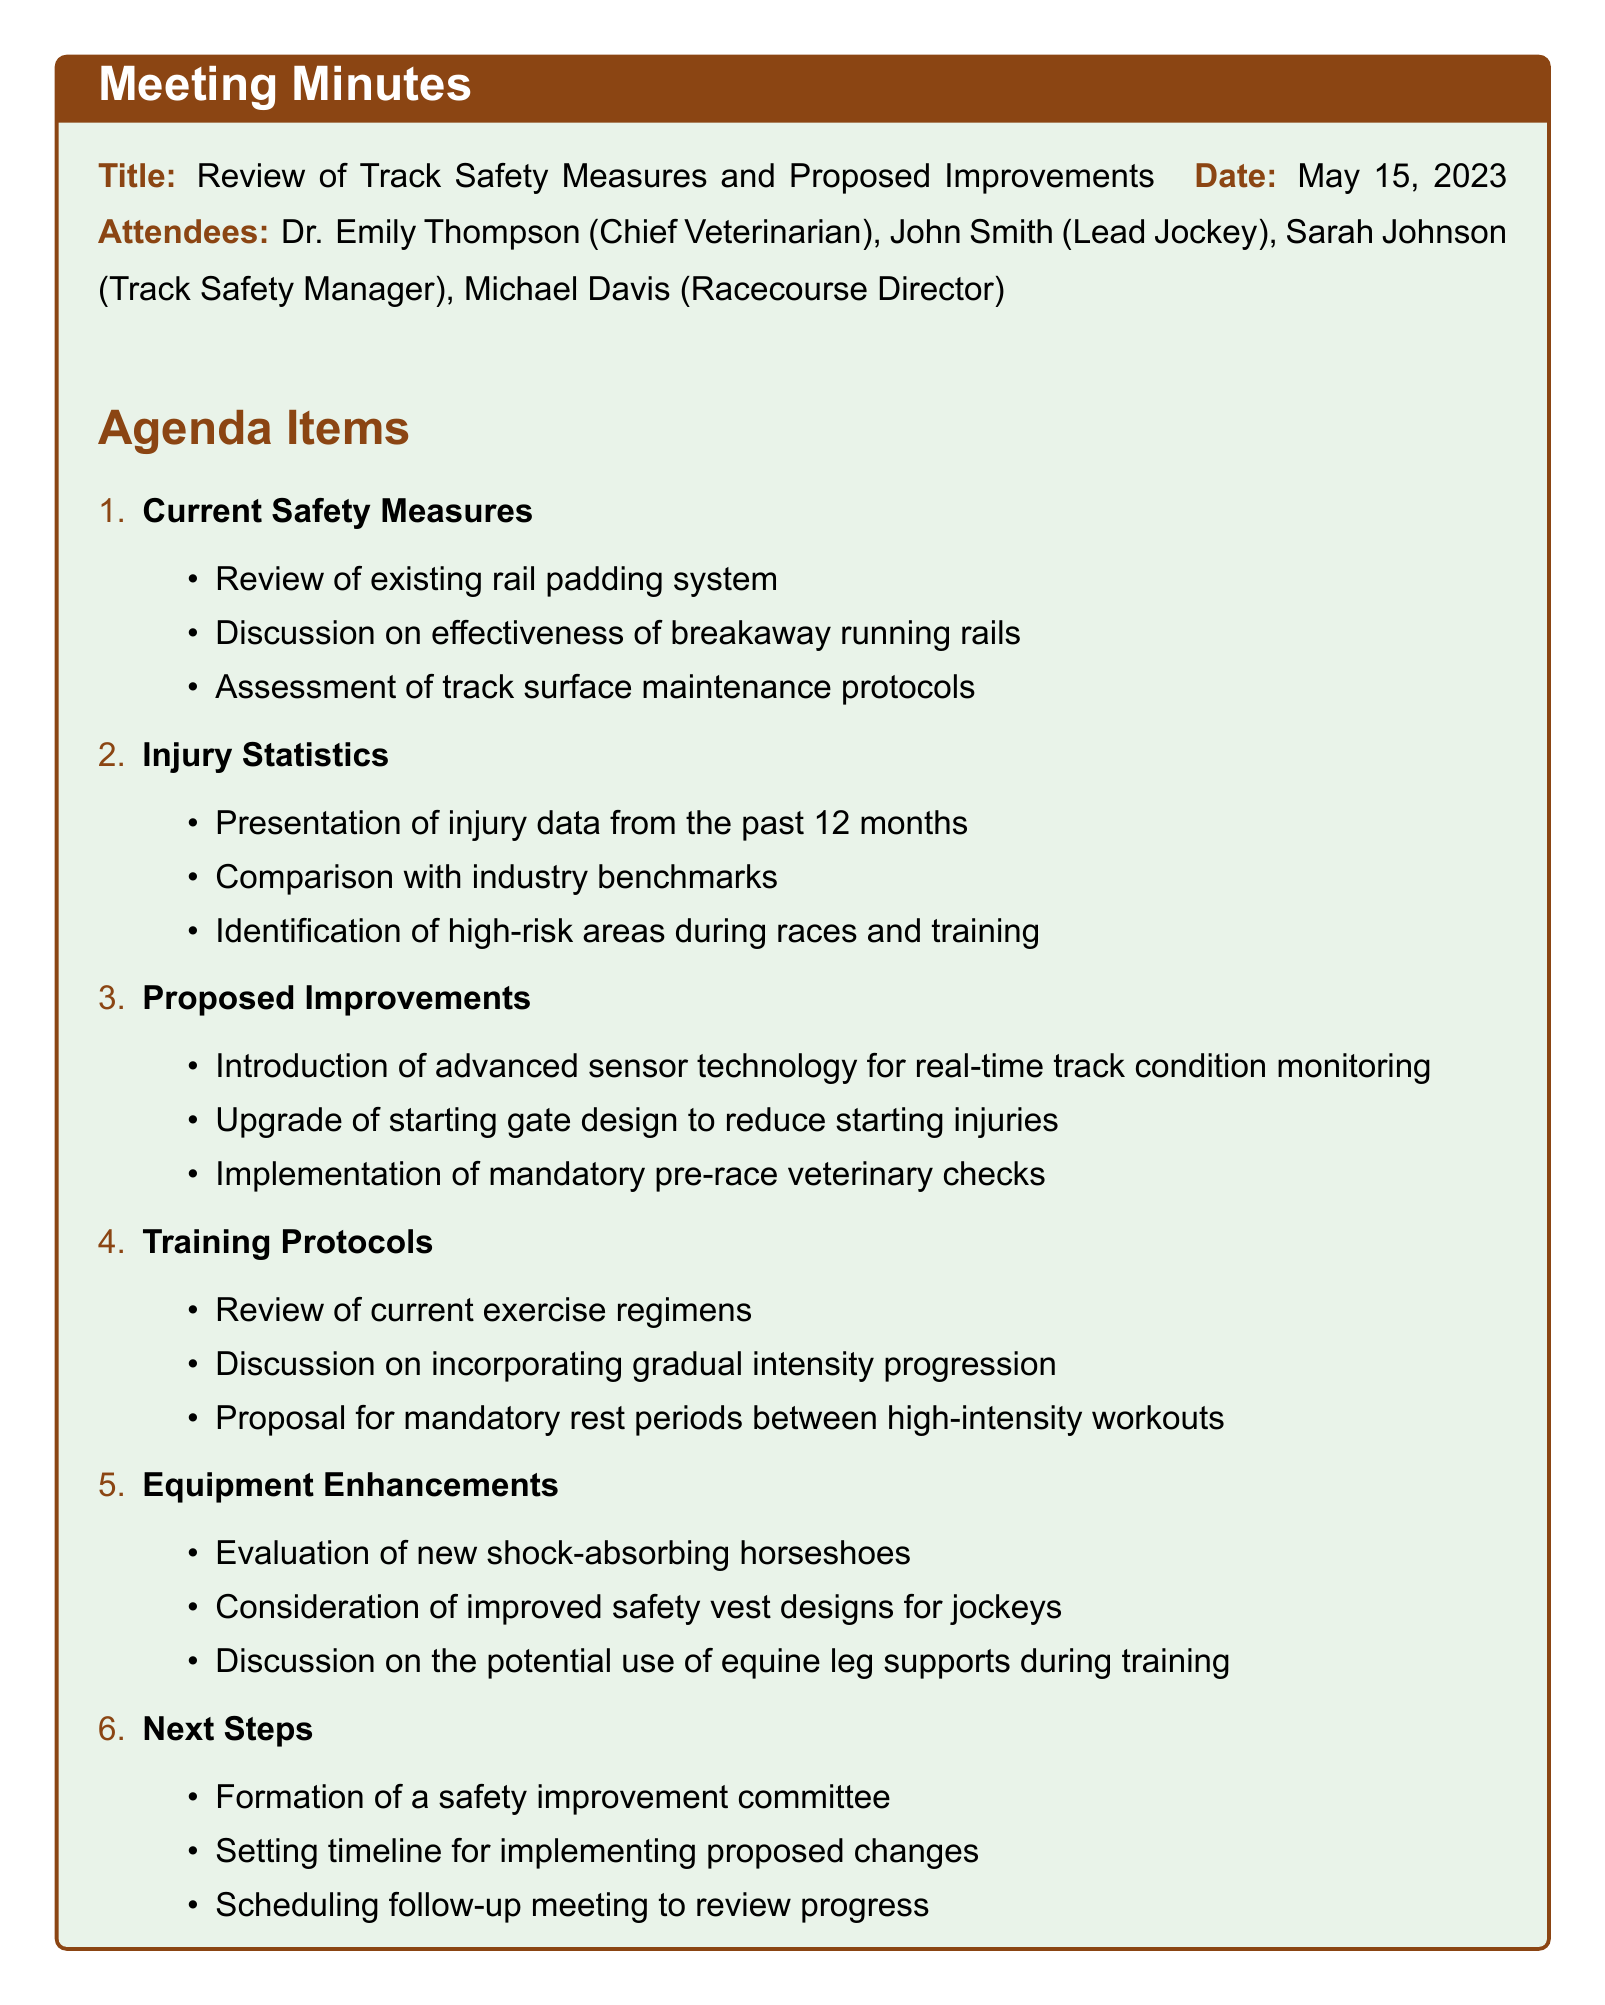What is the date of the meeting? The date of the meeting is explicitly stated in the document as "May 15, 2023."
Answer: May 15, 2023 Who presented the injury statistics? The document lists "Presentation of injury data" but does not specify who presented it. However, the Chief Veterinarian is involved, implying it could be Dr. Emily Thompson.
Answer: Dr. Emily Thompson (implied) What is one proposed improvement related to starting injuries? The document explicitly mentions "Upgrade of starting gate design to reduce starting injuries."
Answer: Upgrade of starting gate design What is the role of Sarah Johnson? Sarah Johnson is listed among attendees, and her title is mentioned as "Track Safety Manager."
Answer: Track Safety Manager What committee is proposed to be formed? The document discusses the "formation of a safety improvement committee" as part of the next steps.
Answer: Safety improvement committee How many attendees were present at the meeting? The attendees listed are four individuals, which can be counted directly from the document.
Answer: Four What is included in the training protocols section? The document states three specific discussion points under training protocols including current exercise regimens, intensity progression, and rest periods.
Answer: Current exercise regimens, gradual intensity progression, mandatory rest periods What is the main topic of the meeting? The primary focus of the meeting is noted as "Review of Track Safety Measures and Proposed Improvements," which sums up the agenda.
Answer: Review of Track Safety Measures and Proposed Improvements What will be scheduled after the meeting? The document mentions "scheduling follow-up meeting to review progress" among the next steps discussed.
Answer: Follow-up meeting to review progress 